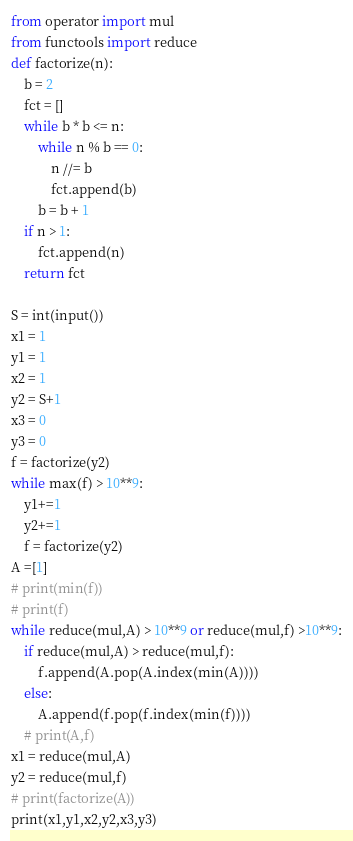<code> <loc_0><loc_0><loc_500><loc_500><_Python_>from operator import mul
from functools import reduce
def factorize(n):
    b = 2
    fct = []
    while b * b <= n:
        while n % b == 0:
            n //= b
            fct.append(b)
        b = b + 1
    if n > 1:
        fct.append(n)
    return fct

S = int(input())
x1 = 1
y1 = 1
x2 = 1
y2 = S+1
x3 = 0
y3 = 0
f = factorize(y2)
while max(f) > 10**9:
    y1+=1
    y2+=1
    f = factorize(y2)
A =[1]
# print(min(f))
# print(f)
while reduce(mul,A) > 10**9 or reduce(mul,f) >10**9:
    if reduce(mul,A) > reduce(mul,f):
        f.append(A.pop(A.index(min(A))))
    else:
        A.append(f.pop(f.index(min(f))))
    # print(A,f)
x1 = reduce(mul,A)
y2 = reduce(mul,f)
# print(factorize(A))
print(x1,y1,x2,y2,x3,y3)</code> 